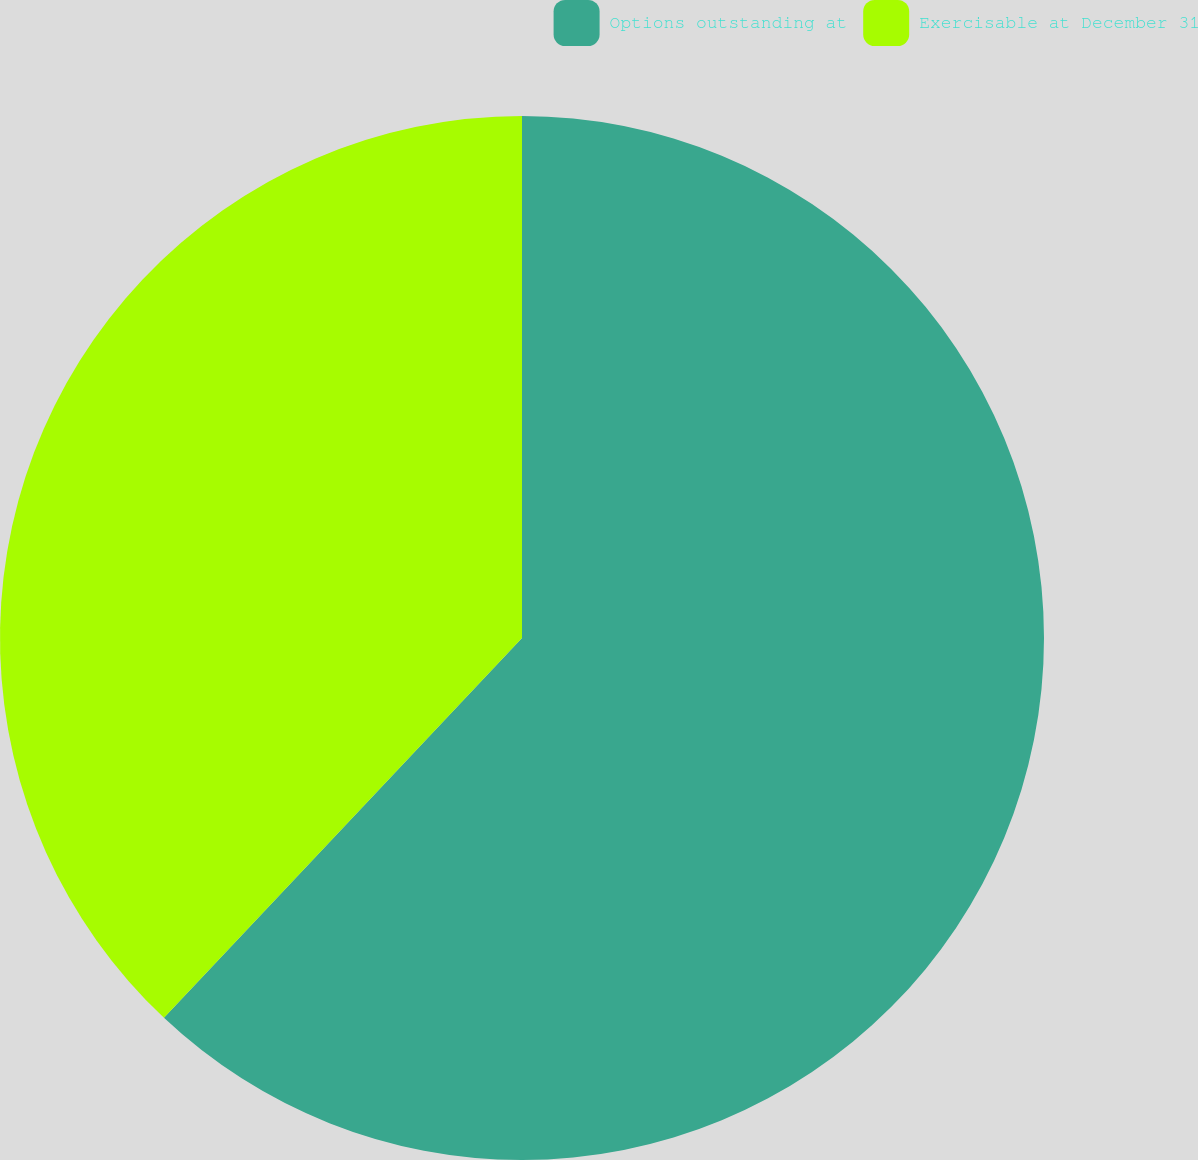Convert chart. <chart><loc_0><loc_0><loc_500><loc_500><pie_chart><fcel>Options outstanding at<fcel>Exercisable at December 31<nl><fcel>62.03%<fcel>37.97%<nl></chart> 